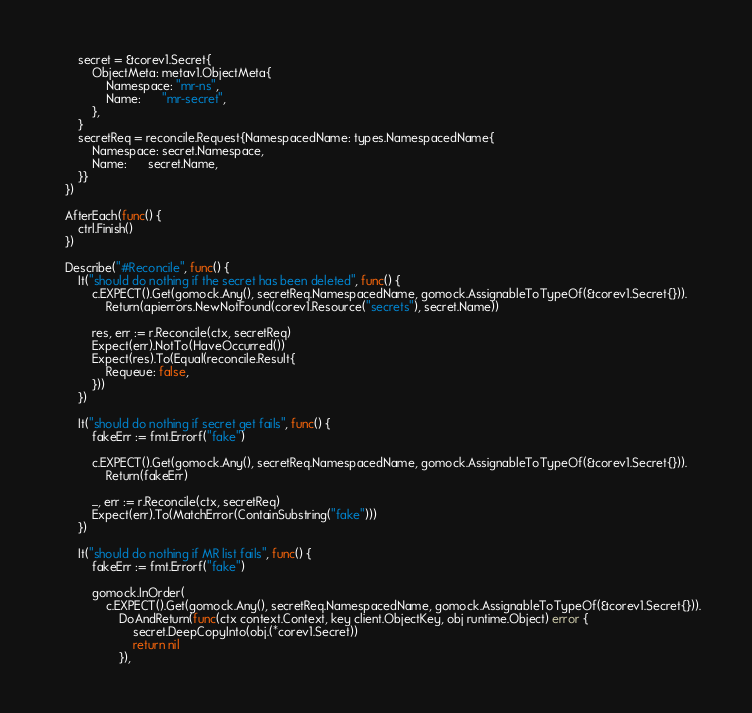Convert code to text. <code><loc_0><loc_0><loc_500><loc_500><_Go_>		secret = &corev1.Secret{
			ObjectMeta: metav1.ObjectMeta{
				Namespace: "mr-ns",
				Name:      "mr-secret",
			},
		}
		secretReq = reconcile.Request{NamespacedName: types.NamespacedName{
			Namespace: secret.Namespace,
			Name:      secret.Name,
		}}
	})

	AfterEach(func() {
		ctrl.Finish()
	})

	Describe("#Reconcile", func() {
		It("should do nothing if the secret has been deleted", func() {
			c.EXPECT().Get(gomock.Any(), secretReq.NamespacedName, gomock.AssignableToTypeOf(&corev1.Secret{})).
				Return(apierrors.NewNotFound(corev1.Resource("secrets"), secret.Name))

			res, err := r.Reconcile(ctx, secretReq)
			Expect(err).NotTo(HaveOccurred())
			Expect(res).To(Equal(reconcile.Result{
				Requeue: false,
			}))
		})

		It("should do nothing if secret get fails", func() {
			fakeErr := fmt.Errorf("fake")

			c.EXPECT().Get(gomock.Any(), secretReq.NamespacedName, gomock.AssignableToTypeOf(&corev1.Secret{})).
				Return(fakeErr)

			_, err := r.Reconcile(ctx, secretReq)
			Expect(err).To(MatchError(ContainSubstring("fake")))
		})

		It("should do nothing if MR list fails", func() {
			fakeErr := fmt.Errorf("fake")

			gomock.InOrder(
				c.EXPECT().Get(gomock.Any(), secretReq.NamespacedName, gomock.AssignableToTypeOf(&corev1.Secret{})).
					DoAndReturn(func(ctx context.Context, key client.ObjectKey, obj runtime.Object) error {
						secret.DeepCopyInto(obj.(*corev1.Secret))
						return nil
					}),</code> 